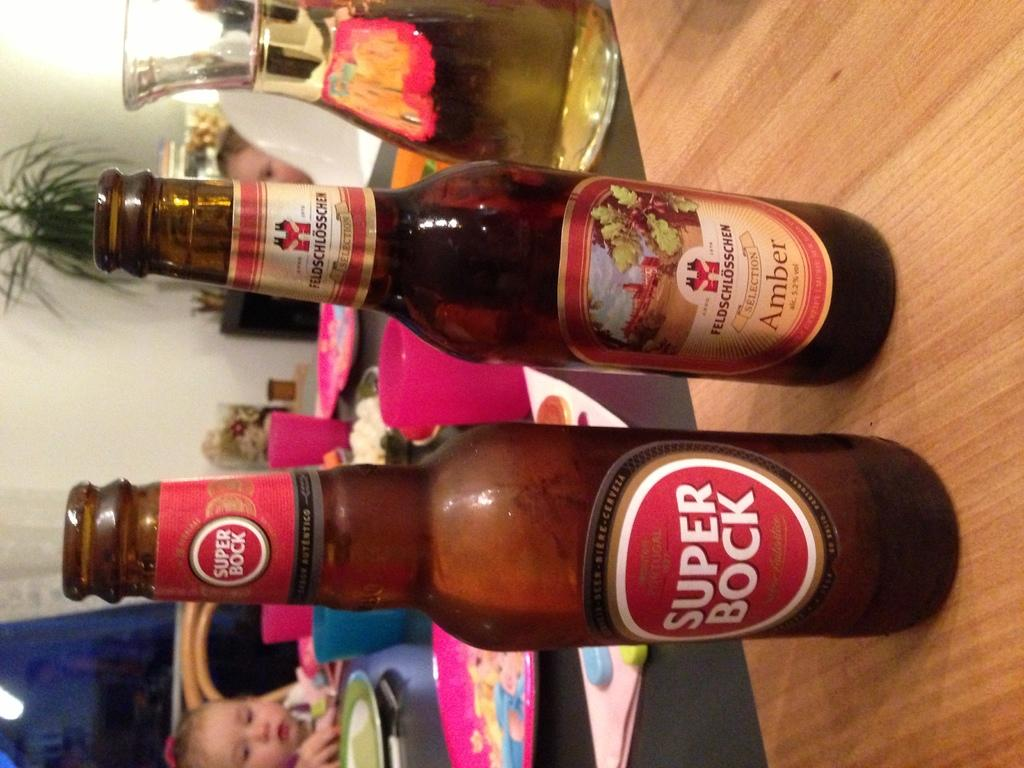Provide a one-sentence caption for the provided image. Bottle of amber and a bottle of super bock sitting on a table. 